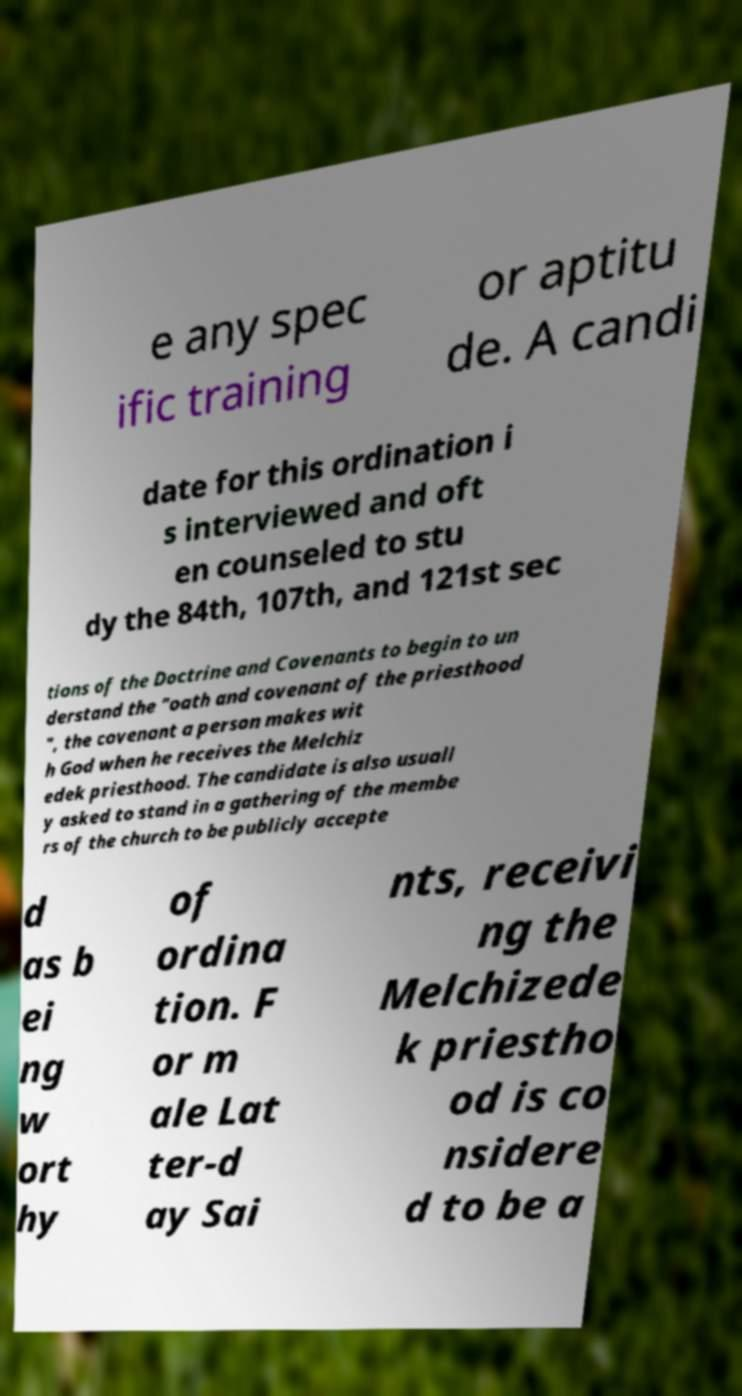Could you assist in decoding the text presented in this image and type it out clearly? e any spec ific training or aptitu de. A candi date for this ordination i s interviewed and oft en counseled to stu dy the 84th, 107th, and 121st sec tions of the Doctrine and Covenants to begin to un derstand the "oath and covenant of the priesthood ", the covenant a person makes wit h God when he receives the Melchiz edek priesthood. The candidate is also usuall y asked to stand in a gathering of the membe rs of the church to be publicly accepte d as b ei ng w ort hy of ordina tion. F or m ale Lat ter-d ay Sai nts, receivi ng the Melchizede k priestho od is co nsidere d to be a 